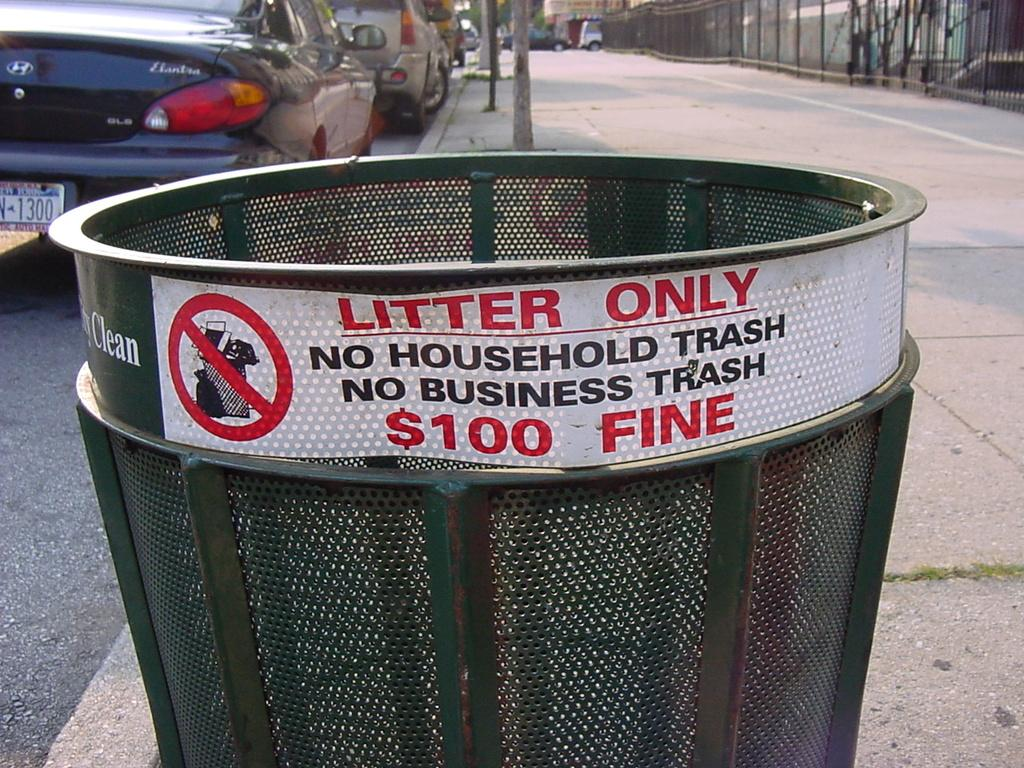<image>
Relay a brief, clear account of the picture shown. you will be fined100 dollars for putting household trash in this can 